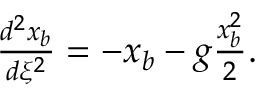Convert formula to latex. <formula><loc_0><loc_0><loc_500><loc_500>\begin{array} { r } { \frac { d ^ { 2 } x _ { b } } { d \xi ^ { 2 } } = - x _ { b } - g \frac { x _ { b } ^ { 2 } } { 2 } . } \end{array}</formula> 